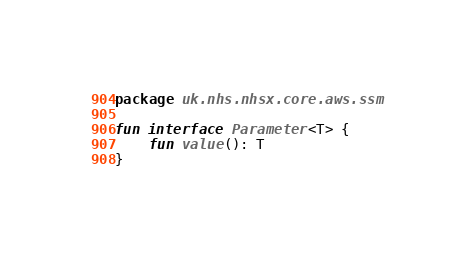Convert code to text. <code><loc_0><loc_0><loc_500><loc_500><_Kotlin_>package uk.nhs.nhsx.core.aws.ssm

fun interface Parameter<T> {
    fun value(): T
}
</code> 